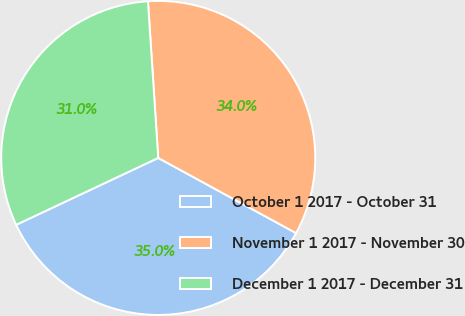<chart> <loc_0><loc_0><loc_500><loc_500><pie_chart><fcel>October 1 2017 - October 31<fcel>November 1 2017 - November 30<fcel>December 1 2017 - December 31<nl><fcel>35.05%<fcel>33.99%<fcel>30.96%<nl></chart> 